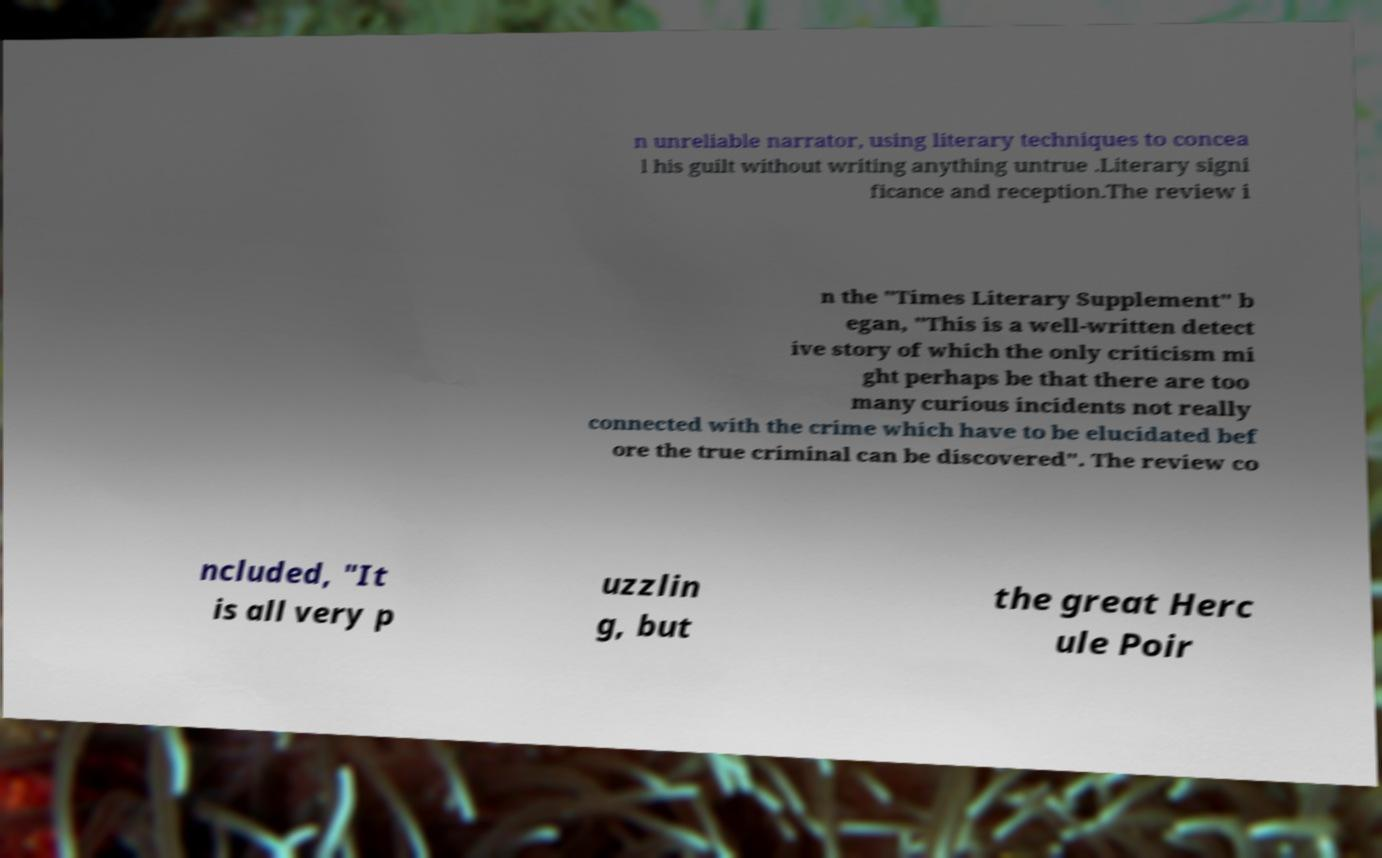Could you extract and type out the text from this image? n unreliable narrator, using literary techniques to concea l his guilt without writing anything untrue .Literary signi ficance and reception.The review i n the "Times Literary Supplement" b egan, "This is a well-written detect ive story of which the only criticism mi ght perhaps be that there are too many curious incidents not really connected with the crime which have to be elucidated bef ore the true criminal can be discovered". The review co ncluded, "It is all very p uzzlin g, but the great Herc ule Poir 